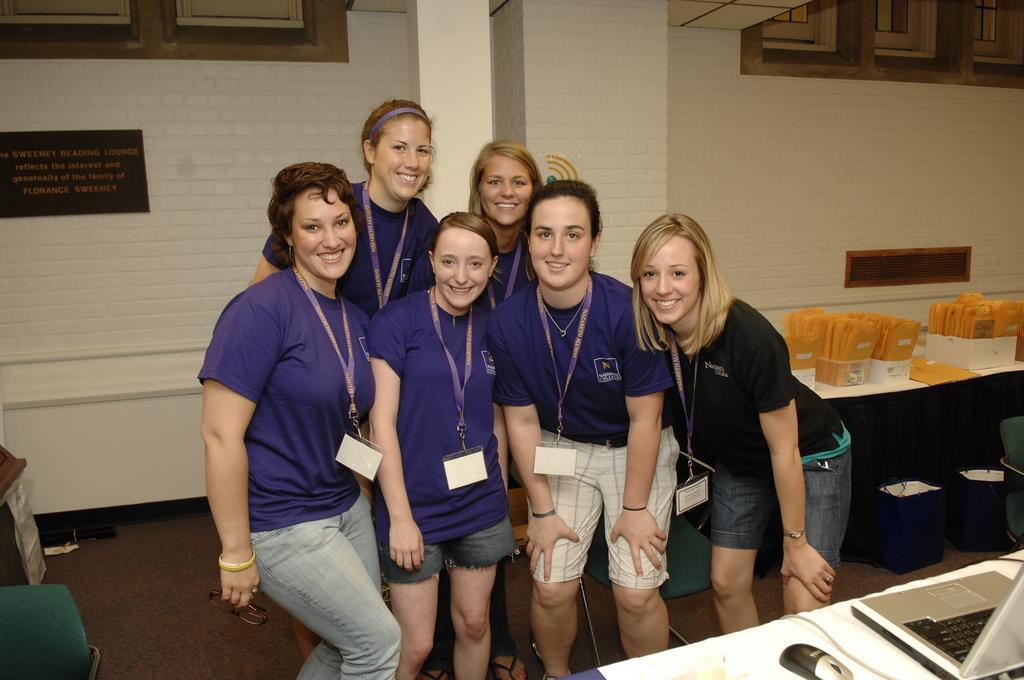Could you give a brief overview of what you see in this image? In this image I can see a group of people. On the right side, I can see some objects on the table. In the background, I can see the wall. 